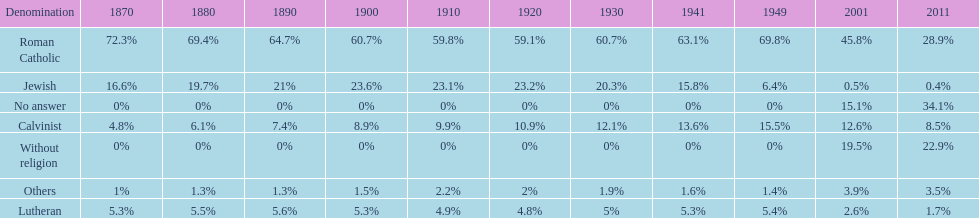In which year was the percentage of those without religion at least 20%? 2011. 